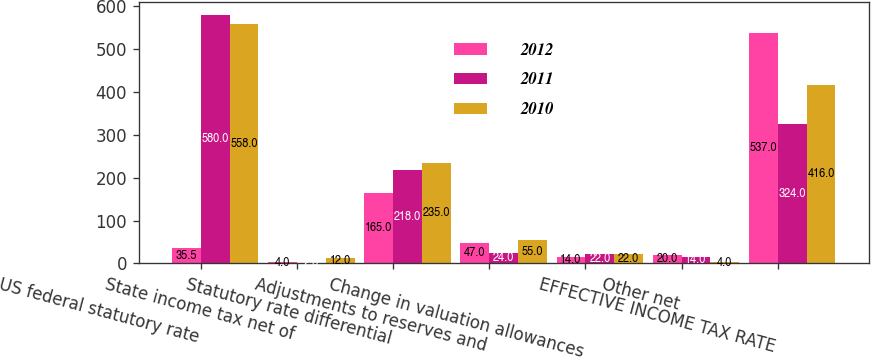Convert chart. <chart><loc_0><loc_0><loc_500><loc_500><stacked_bar_chart><ecel><fcel>US federal statutory rate<fcel>State income tax net of<fcel>Statutory rate differential<fcel>Adjustments to reserves and<fcel>Change in valuation allowances<fcel>Other net<fcel>EFFECTIVE INCOME TAX RATE<nl><fcel>2012<fcel>35.5<fcel>4<fcel>165<fcel>47<fcel>14<fcel>20<fcel>537<nl><fcel>2011<fcel>580<fcel>2<fcel>218<fcel>24<fcel>22<fcel>14<fcel>324<nl><fcel>2010<fcel>558<fcel>12<fcel>235<fcel>55<fcel>22<fcel>4<fcel>416<nl></chart> 